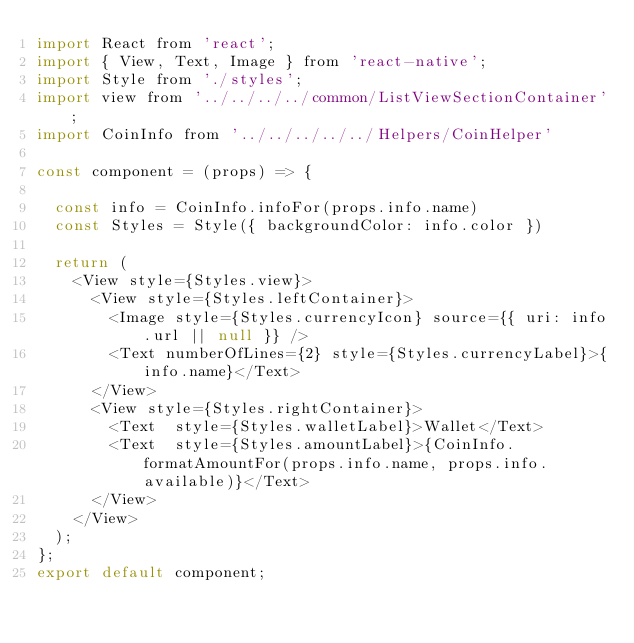Convert code to text. <code><loc_0><loc_0><loc_500><loc_500><_JavaScript_>import React from 'react';
import { View, Text, Image } from 'react-native';
import Style from './styles';
import view from '../../../../common/ListViewSectionContainer';
import CoinInfo from '../../../../../Helpers/CoinHelper'

const component = (props) => {

  const info = CoinInfo.infoFor(props.info.name)
  const Styles = Style({ backgroundColor: info.color })

  return (
    <View style={Styles.view}>
      <View style={Styles.leftContainer}>
        <Image style={Styles.currencyIcon} source={{ uri: info.url || null }} />
        <Text numberOfLines={2} style={Styles.currencyLabel}>{info.name}</Text>
      </View>
      <View style={Styles.rightContainer}>
        <Text  style={Styles.walletLabel}>Wallet</Text>
        <Text  style={Styles.amountLabel}>{CoinInfo.formatAmountFor(props.info.name, props.info.available)}</Text>
      </View>
    </View>
  );
};
export default component;
</code> 